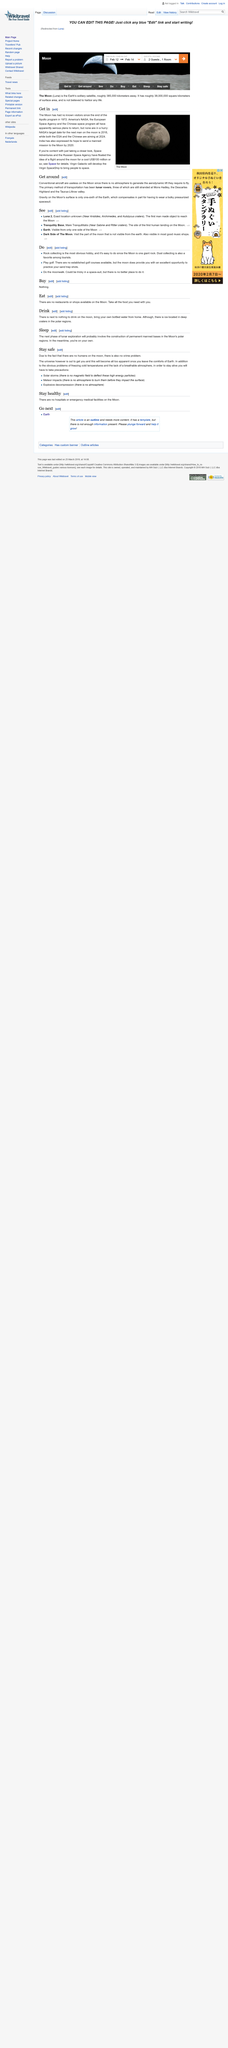Point out several critical features in this image. NASA had set the target date for the next manned mission to the Moon as 2018. India plans to launch a manned mission to the Moon by 2020. The photograph depicts the moon. 